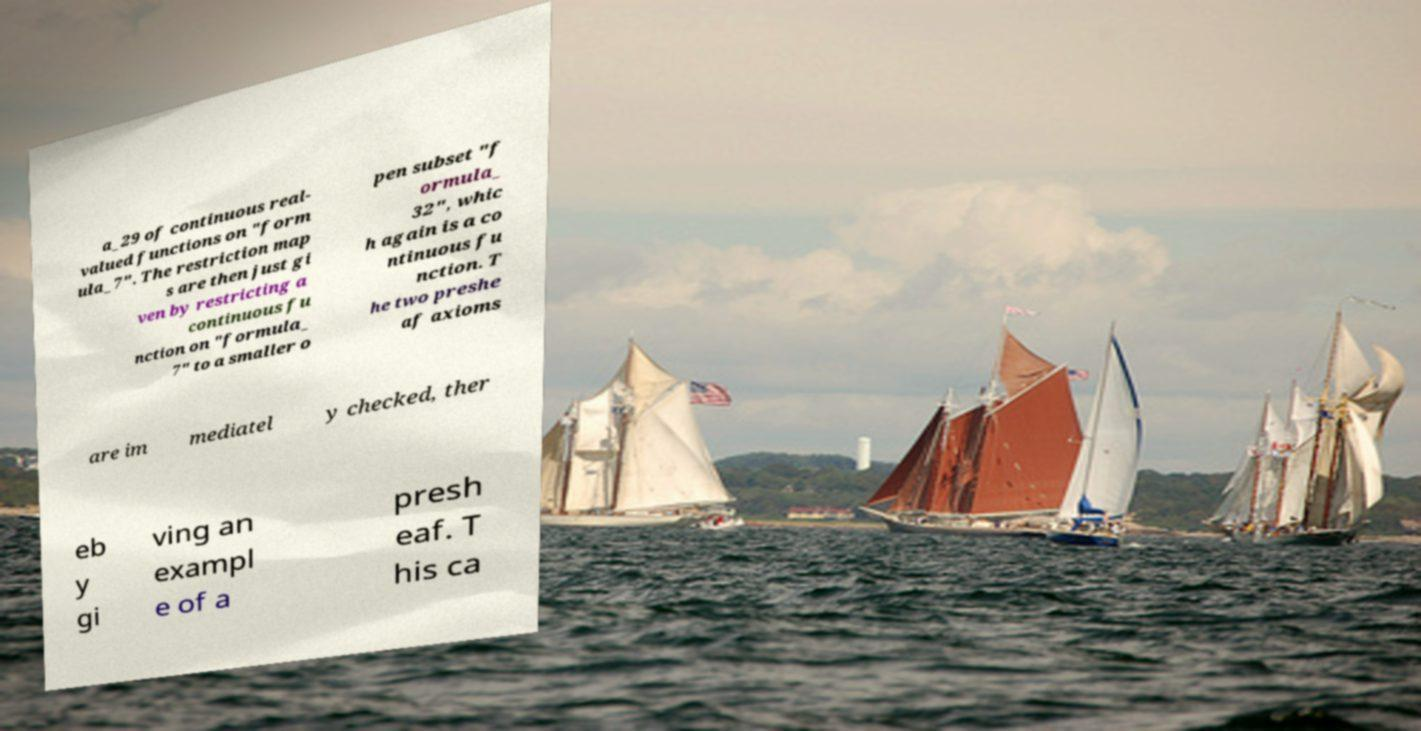Could you extract and type out the text from this image? a_29 of continuous real- valued functions on "form ula_7". The restriction map s are then just gi ven by restricting a continuous fu nction on "formula_ 7" to a smaller o pen subset "f ormula_ 32", whic h again is a co ntinuous fu nction. T he two preshe af axioms are im mediatel y checked, ther eb y gi ving an exampl e of a presh eaf. T his ca 